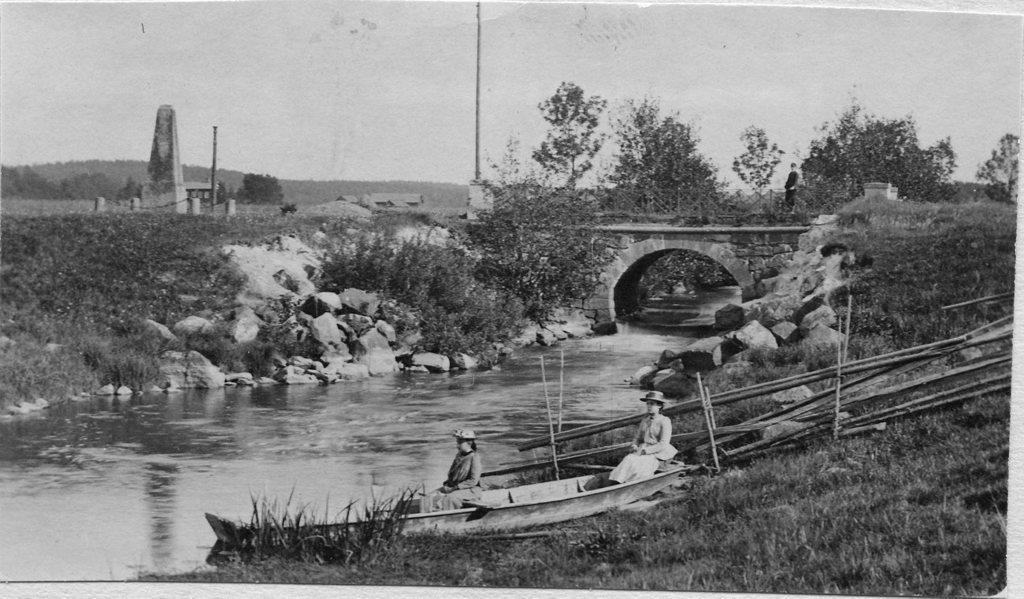Could you give a brief overview of what you see in this image? In this image in the front there is grass on the ground and there is a boat with the persons sitting in the boat. In the center there is water, there are stones and in the background there are trees and there is a bridge, there are poles and there is wall and there are mountains and there is a person standing on the bridge. 